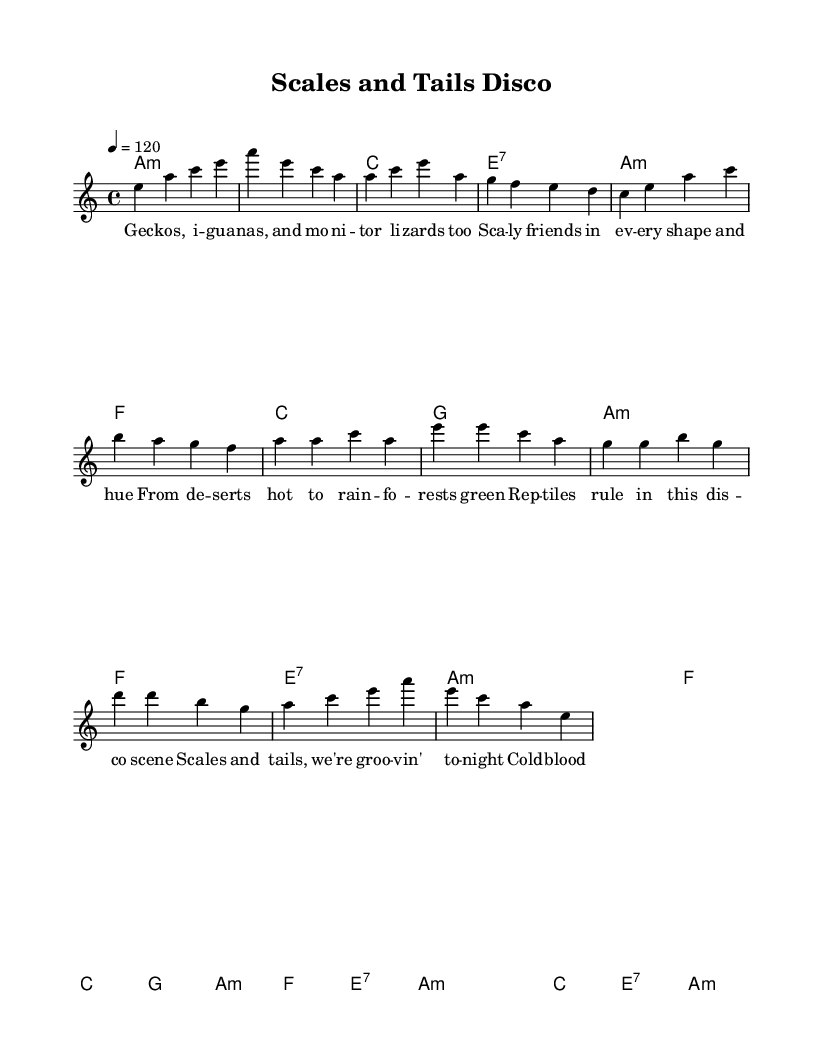What is the key signature of this music? The key signature is A minor, which typically has no sharps or flats. It indicates that the music will primarily use the notes of the A natural minor scale.
Answer: A minor What is the time signature of this music? The time signature is 4/4, which means there are four beats in each measure and a quarter note receives one beat. This is a common time signature for disco music, providing a steady rhythm.
Answer: 4/4 What is the tempo of this music? The tempo is marked as quarter note equals 120 beats per minute. This tempo indicates a moderate disco pace, which helps to create an energetic atmosphere for dancing.
Answer: 120 How many measures are in the verse? The verse consists of eight measures, as counted from the beginning of the verse lyrics, starting from the first line until the last complete line before the chorus begins.
Answer: 8 What is the repeated section in the chorus? The chorus features the lines "Scales and tails, we're groovin' tonight" and "Cold-blooded creatures under disco lights," which are both repeated for a strong emphasis on the disco theme and celebration of reptiles.
Answer: "Scales and tails, we're groovin' tonight" and "Cold-blooded creatures under disco lights." Which reptile species is specifically mentioned in the verse? The verse mentions iguanas and monitor lizards, highlighting the diversity of lizard species and their different habitats. This contributes to the celebration of reptiles within the disco theme.
Answer: Iguanas and monitor lizards 